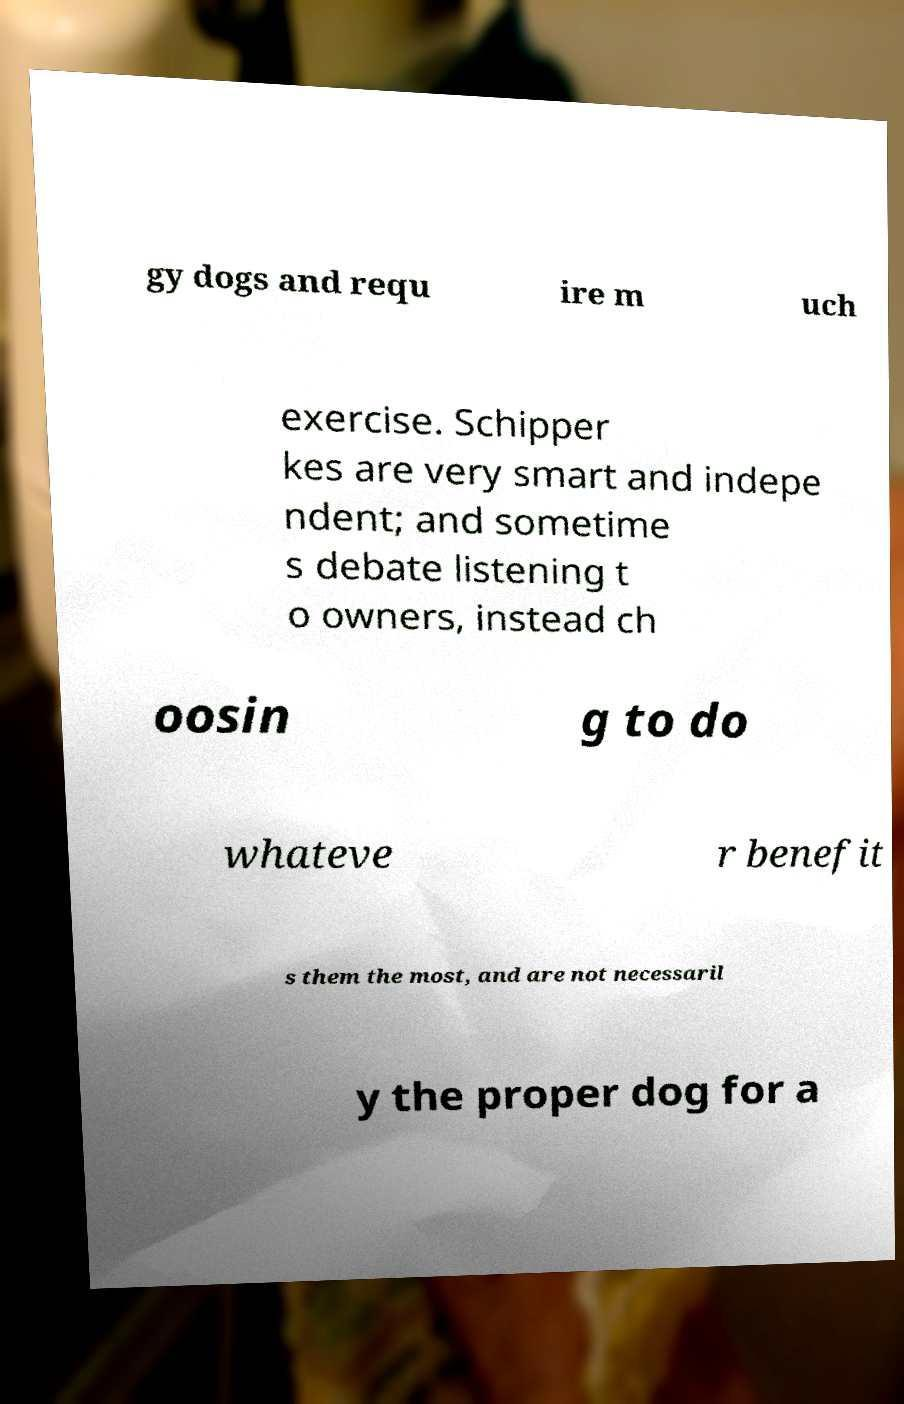Can you accurately transcribe the text from the provided image for me? gy dogs and requ ire m uch exercise. Schipper kes are very smart and indepe ndent; and sometime s debate listening t o owners, instead ch oosin g to do whateve r benefit s them the most, and are not necessaril y the proper dog for a 